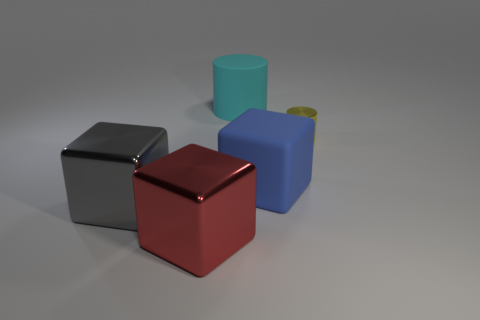Add 5 big yellow cubes. How many objects exist? 10 Subtract 1 cubes. How many cubes are left? 2 Subtract all cubes. How many objects are left? 2 Subtract all large blue metallic objects. Subtract all gray shiny cubes. How many objects are left? 4 Add 4 big metallic objects. How many big metallic objects are left? 6 Add 1 large red metal blocks. How many large red metal blocks exist? 2 Subtract 0 yellow balls. How many objects are left? 5 